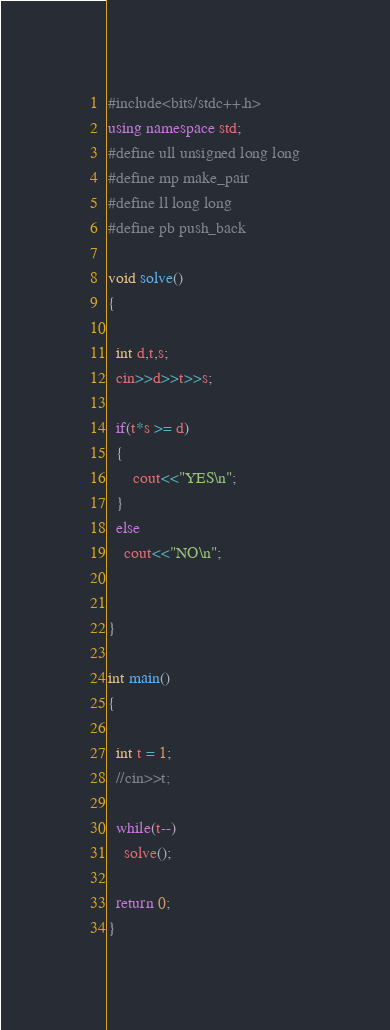Convert code to text. <code><loc_0><loc_0><loc_500><loc_500><_C++_>#include<bits/stdc++.h>
using namespace std;
#define ull unsigned long long
#define mp make_pair
#define ll long long
#define pb push_back

void solve()
{
  
  int d,t,s;
  cin>>d>>t>>s;
  
  if(t*s >= d)
  {
      cout<<"YES\n";
  }
  else
    cout<<"NO\n";
  
  
}

int main()
{

  int t = 1;
  //cin>>t;

  while(t--)
    solve();

  return 0;
}
</code> 